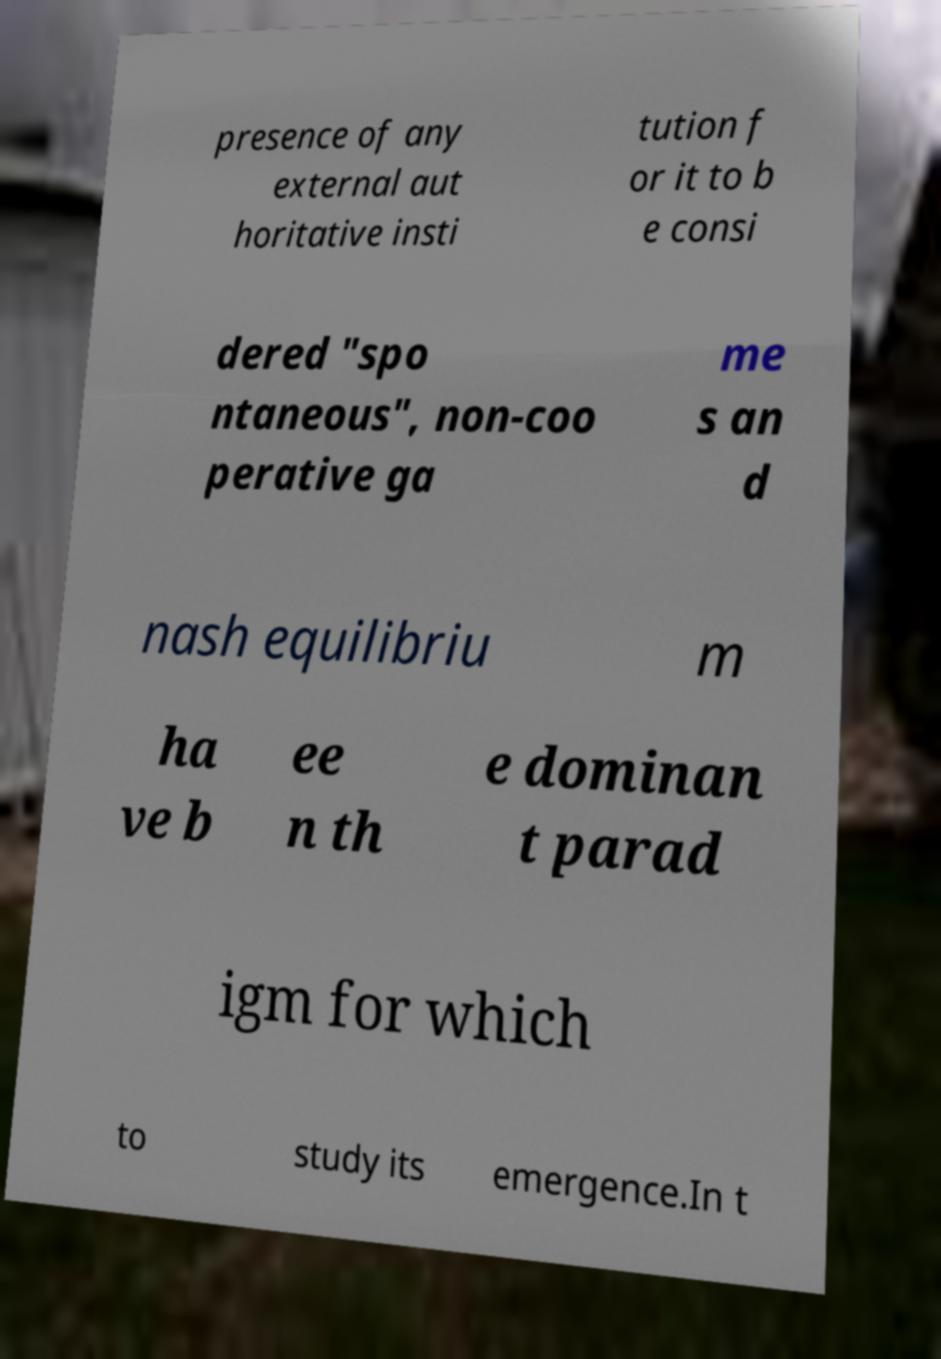I need the written content from this picture converted into text. Can you do that? presence of any external aut horitative insti tution f or it to b e consi dered "spo ntaneous", non-coo perative ga me s an d nash equilibriu m ha ve b ee n th e dominan t parad igm for which to study its emergence.In t 